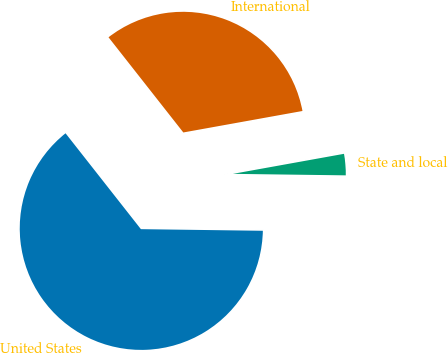Convert chart to OTSL. <chart><loc_0><loc_0><loc_500><loc_500><pie_chart><fcel>United States<fcel>State and local<fcel>International<nl><fcel>64.18%<fcel>3.05%<fcel>32.76%<nl></chart> 